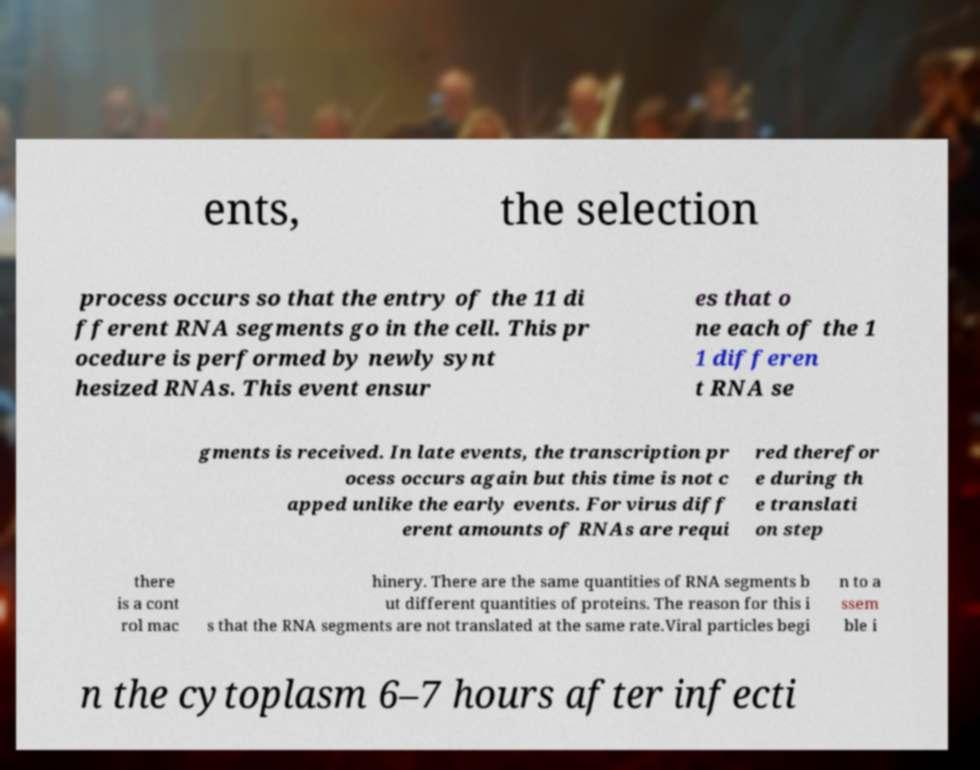Could you extract and type out the text from this image? ents, the selection process occurs so that the entry of the 11 di fferent RNA segments go in the cell. This pr ocedure is performed by newly synt hesized RNAs. This event ensur es that o ne each of the 1 1 differen t RNA se gments is received. In late events, the transcription pr ocess occurs again but this time is not c apped unlike the early events. For virus diff erent amounts of RNAs are requi red therefor e during th e translati on step there is a cont rol mac hinery. There are the same quantities of RNA segments b ut different quantities of proteins. The reason for this i s that the RNA segments are not translated at the same rate.Viral particles begi n to a ssem ble i n the cytoplasm 6–7 hours after infecti 